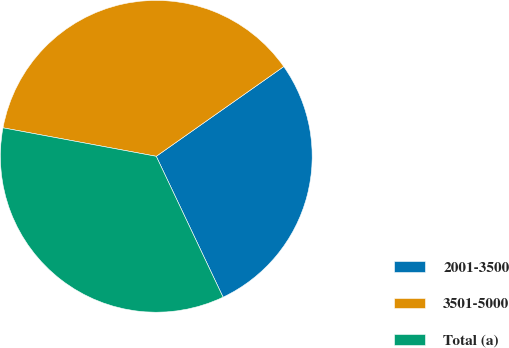Convert chart. <chart><loc_0><loc_0><loc_500><loc_500><pie_chart><fcel>2001-3500<fcel>3501-5000<fcel>Total (a)<nl><fcel>27.71%<fcel>37.31%<fcel>34.97%<nl></chart> 